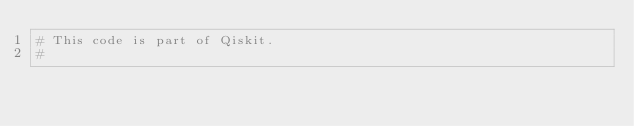Convert code to text. <code><loc_0><loc_0><loc_500><loc_500><_Python_># This code is part of Qiskit.
#</code> 